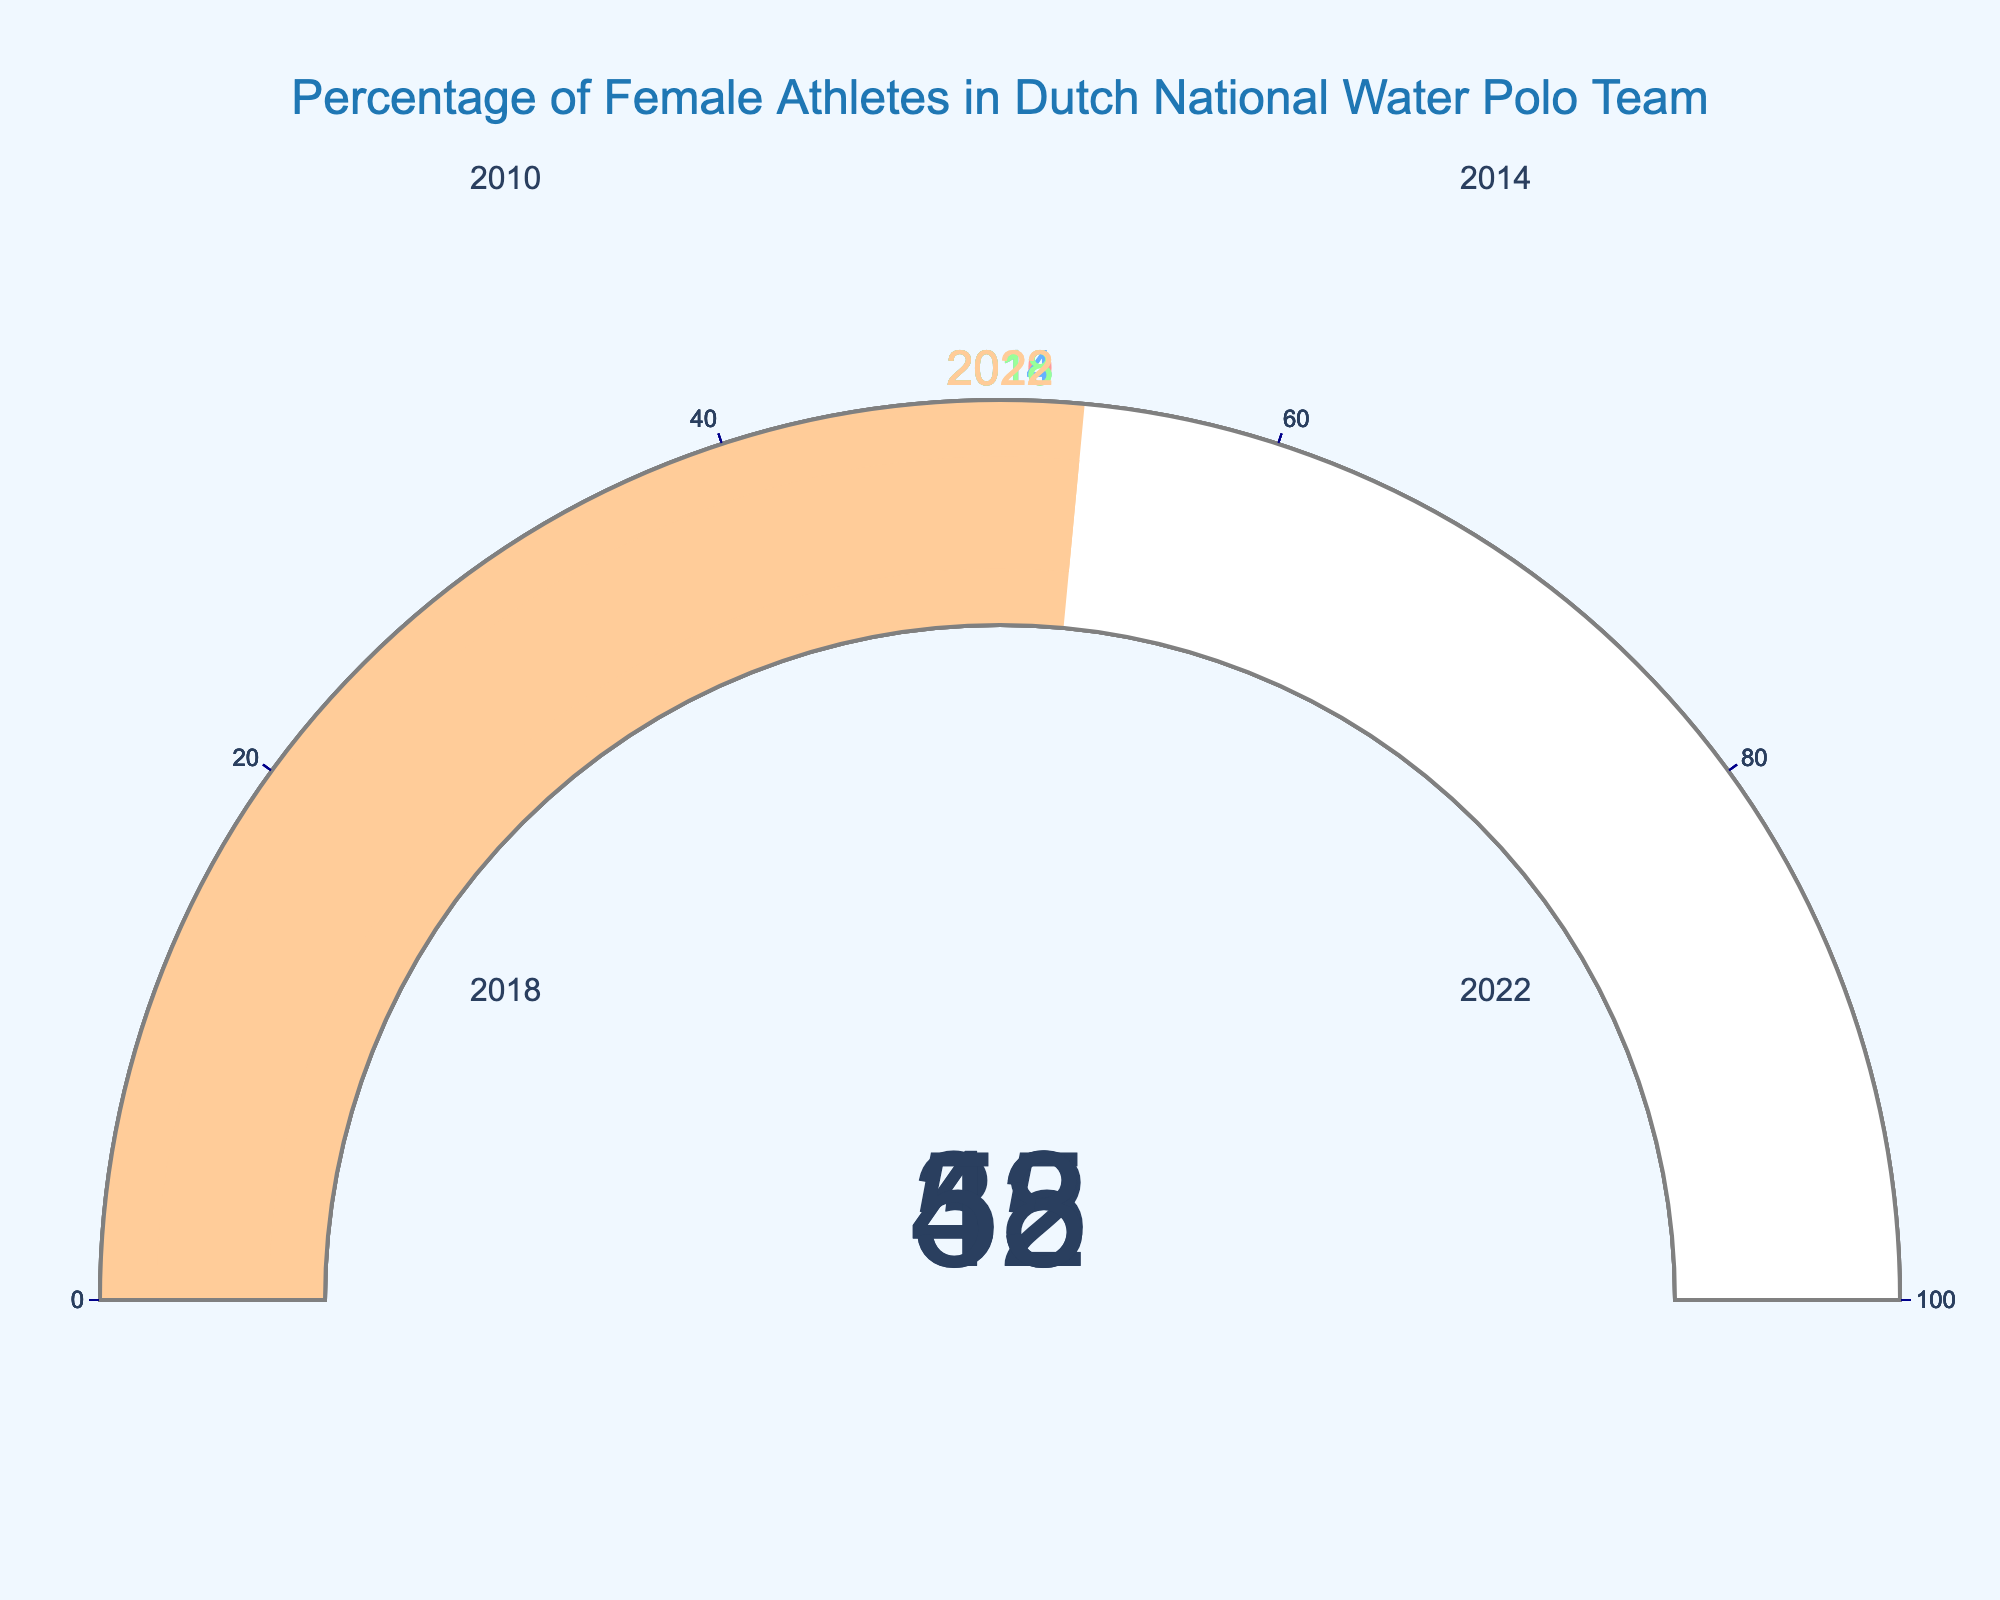What is the percentage of female athletes in 2022? The gauge chart for the year 2022 shows a value of 53%.
Answer: 53% How has the percentage of female athletes changed from 2010 to 2022? To find the change, subtract the percentage in 2010 (35%) from the percentage in 2022 (53%). The difference is 53% - 35% = 18%.
Answer: 18% Which year had the highest percentage of female athletes? By comparing the gauges for all years, 2022 has the highest percentage at 53%.
Answer: 2022 Calculate the average percentage of female athletes across all displayed years. Sum the percentages for 2010 (35%), 2014 (42%), 2018 (48%), and 2022 (53%). The total is 35 + 42 + 48 + 53 = 178. Dividing by the number of years (4) gives 178 / 4 = 44.5%.
Answer: 44.5% What is the difference in percentage of female athletes between 2014 and 2018? Subtract the percentage in 2014 (42%) from the percentage in 2018 (48%). The difference is 48% - 42% = 6%.
Answer: 6% Identify the trend in the percentage of female athletes over the four years shown. The figure shows a continuous increase in the percentage of female athletes: 35% in 2010, 42% in 2014, 48% in 2018, and 53% in 2022.
Answer: Increasing What is the range of percentages of female athletes across the years displayed? The range is calculated by subtracting the smallest percentage (35% in 2010) from the largest percentage (53% in 2022). The range is 53% - 35% = 18%.
Answer: 18% Which year had the smallest increase in the percentage of female athletes compared to the previous year? Calculate the increase for each period: 
- 2010 to 2014: 42% - 35% = 7%
- 2014 to 2018: 48% - 42% = 6%
- 2018 to 2022: 53% - 48% = 5%
2018 to 2022 had the smallest increase (5%).
Answer: 2018 to 2022 What is the median percentage of female athletes from the given years? Arrange the percentages in ascending order: 35, 42, 48, 53. The median is the average of the two middle numbers (42 and 48). So, (42 + 48) / 2 = 45%.
Answer: 45% 